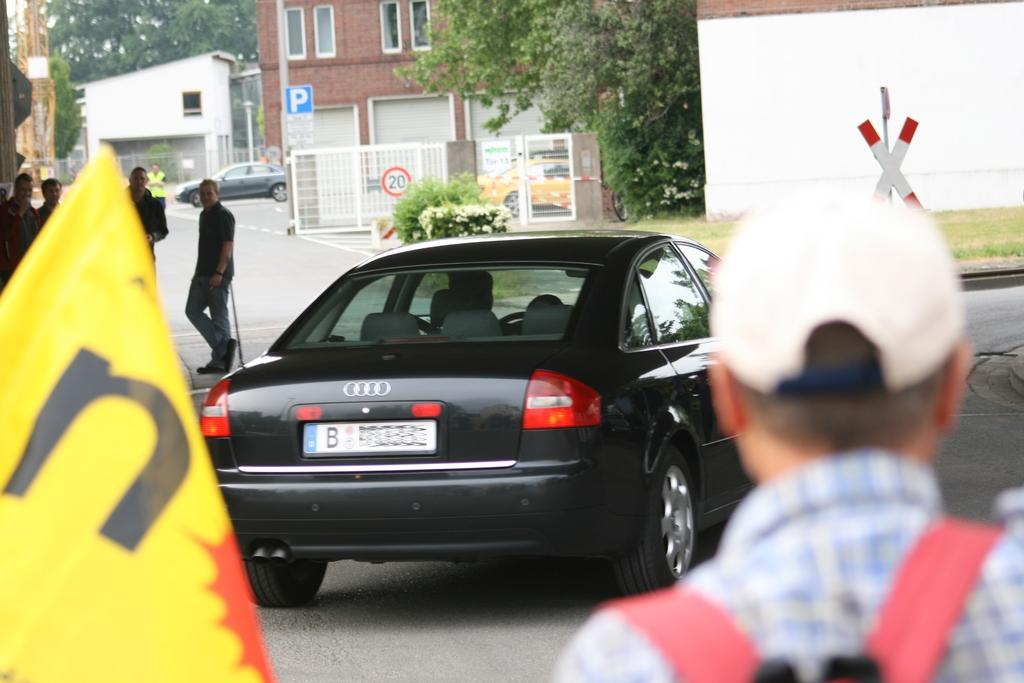<image>
Render a clear and concise summary of the photo. the letter B that is on the back of a license plate 